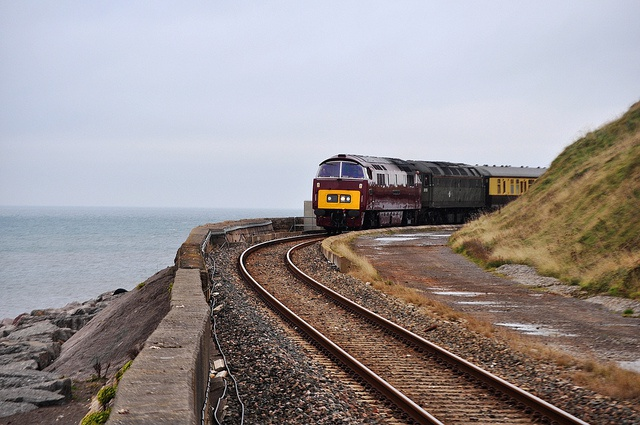Describe the objects in this image and their specific colors. I can see a train in lightgray, black, gray, darkgray, and maroon tones in this image. 